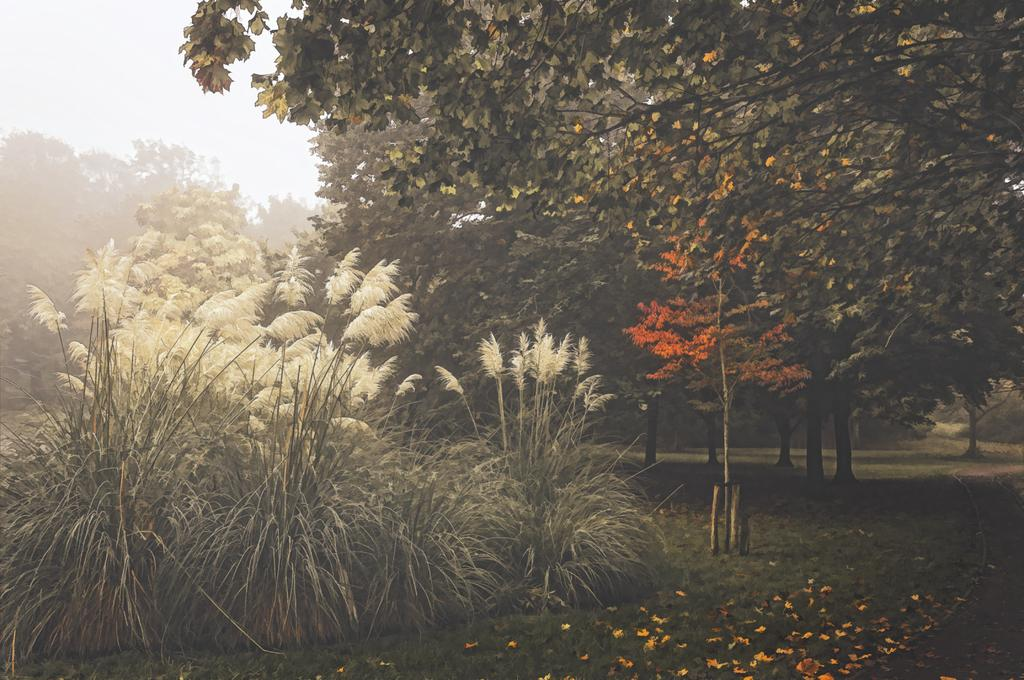What type of vegetation can be seen in the image? There is grass, shrubs, and trees in the image. Can you describe the background of the image? The background of the image includes fog and the sky. What is the primary element that makes up the landscape in the image? The primary element in the landscape is vegetation, including grass, shrubs, and trees. What type of plot is being used to grow the vegetables in the image? There are no vegetables present in the image, only grass, shrubs, and trees. What type of mask is being worn by the trees in the image? There are no masks present in the image; the trees are not wearing any masks. 